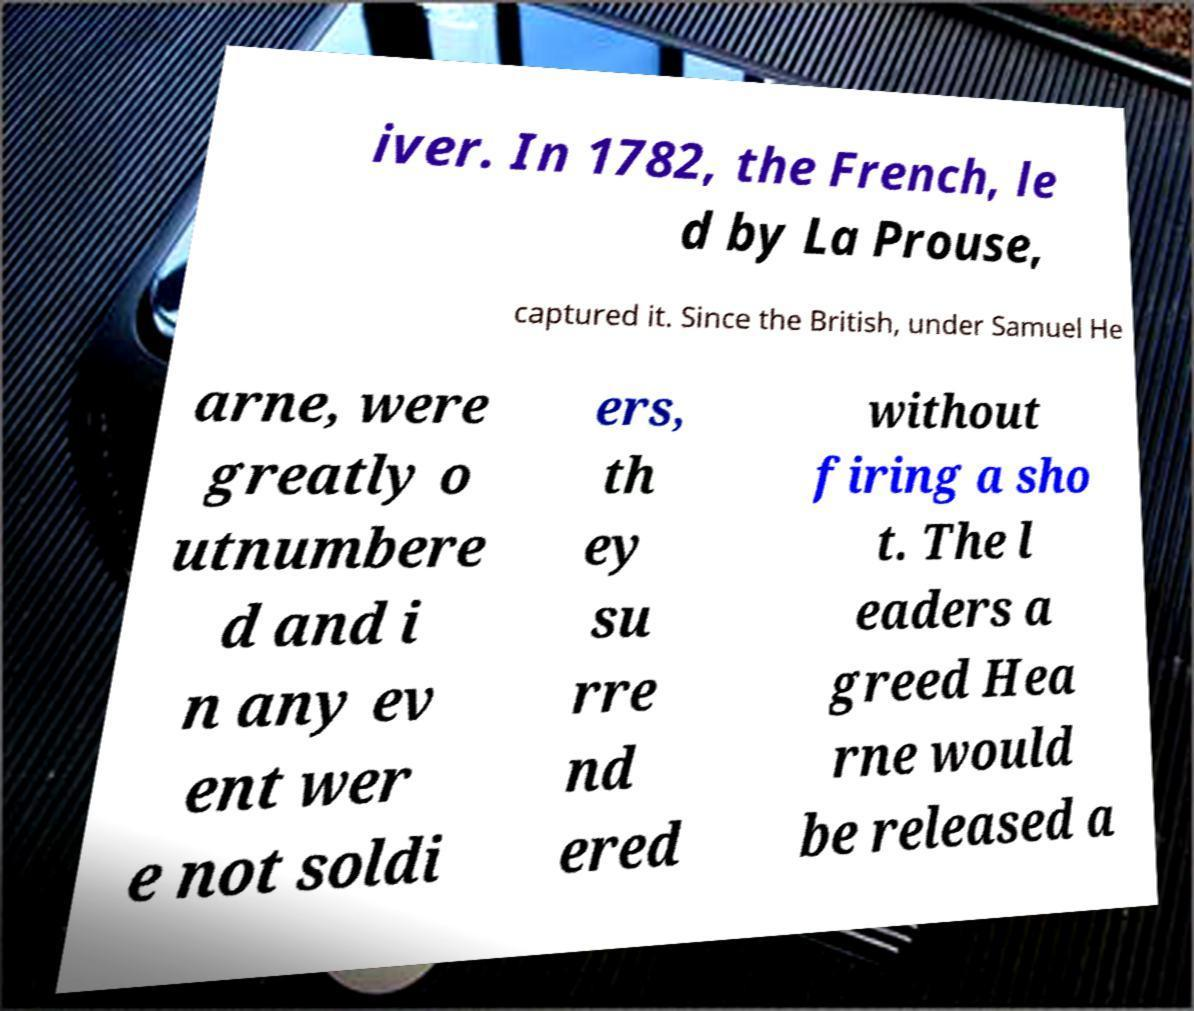For documentation purposes, I need the text within this image transcribed. Could you provide that? iver. In 1782, the French, le d by La Prouse, captured it. Since the British, under Samuel He arne, were greatly o utnumbere d and i n any ev ent wer e not soldi ers, th ey su rre nd ered without firing a sho t. The l eaders a greed Hea rne would be released a 